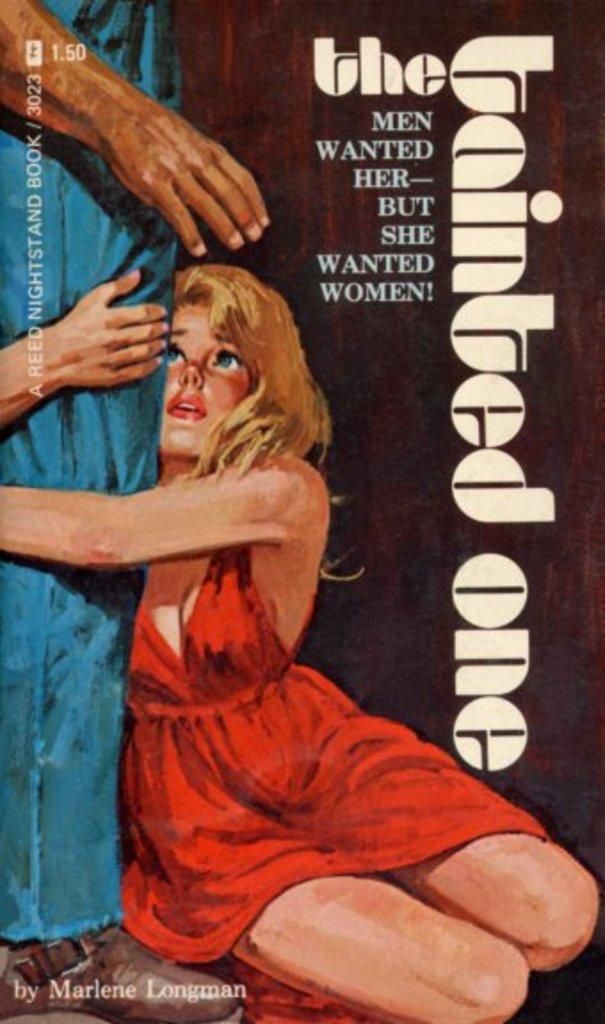Provide a one-sentence caption for the provided image. The cover of The Tainted One has a girl wearing a red dress. 